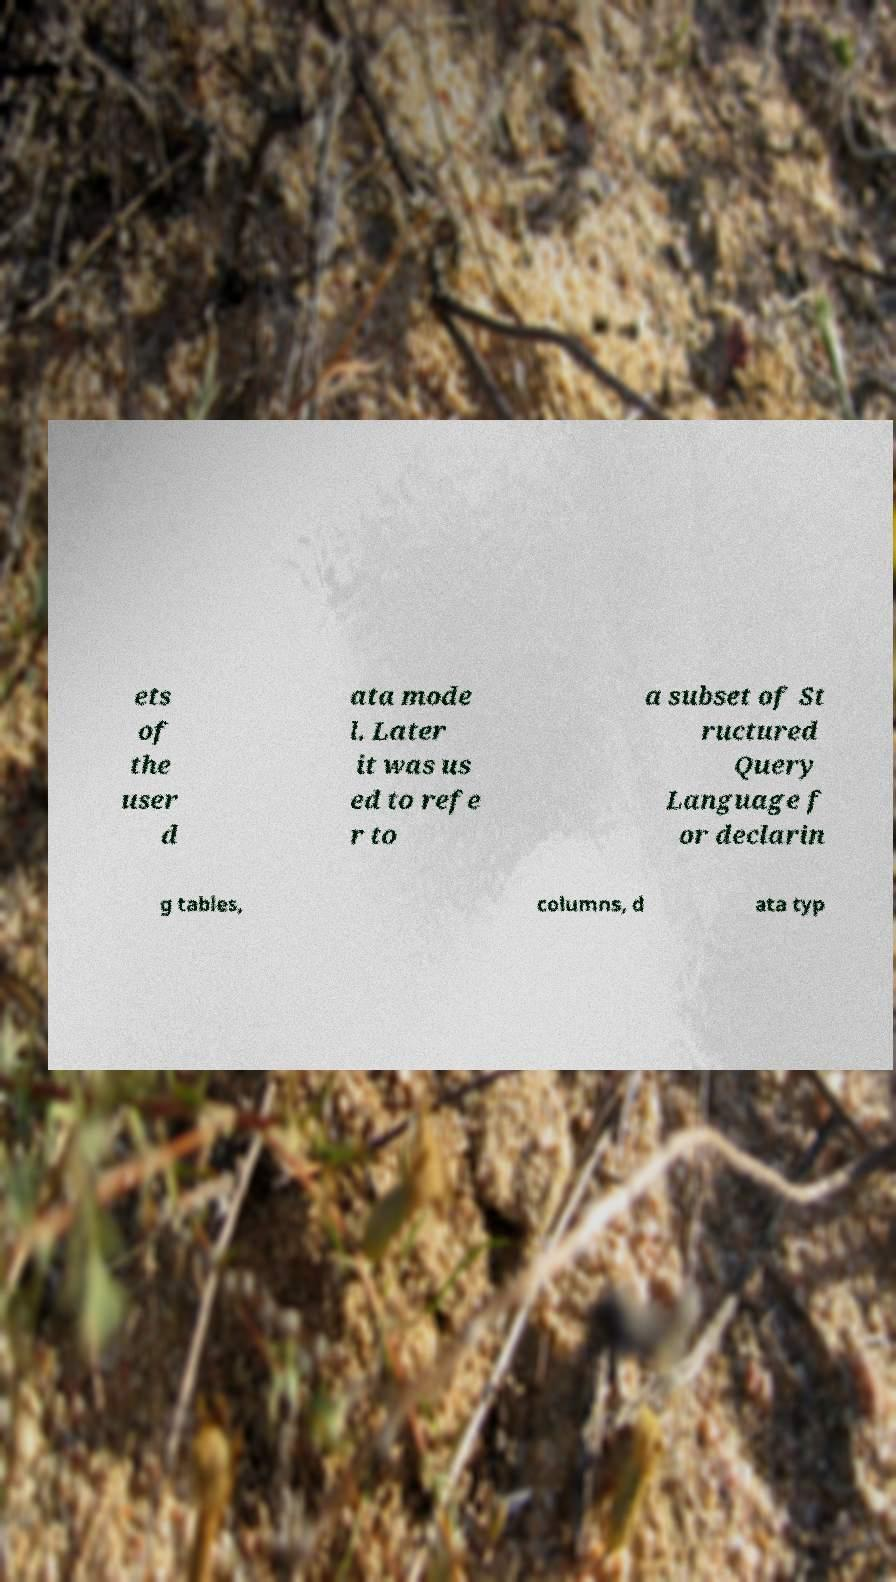Please identify and transcribe the text found in this image. ets of the user d ata mode l. Later it was us ed to refe r to a subset of St ructured Query Language f or declarin g tables, columns, d ata typ 